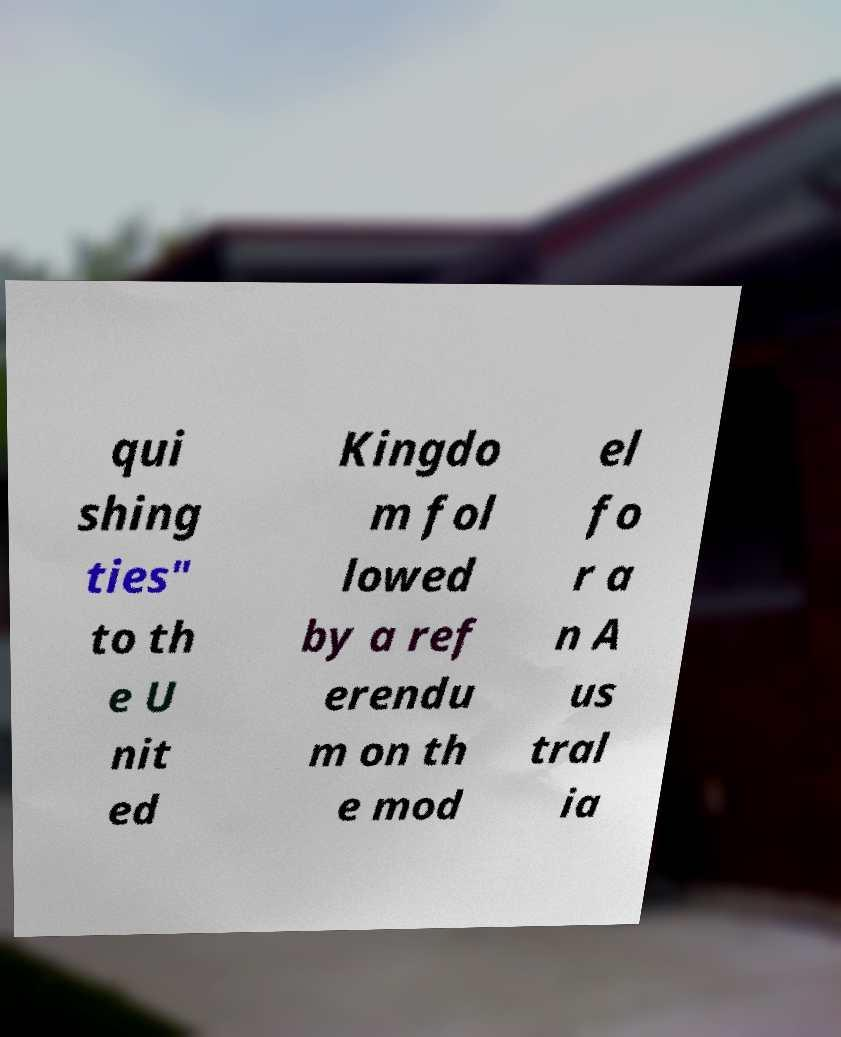Can you read and provide the text displayed in the image?This photo seems to have some interesting text. Can you extract and type it out for me? qui shing ties" to th e U nit ed Kingdo m fol lowed by a ref erendu m on th e mod el fo r a n A us tral ia 